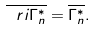Convert formula to latex. <formula><loc_0><loc_0><loc_500><loc_500>\overline { \ r i { \Gamma ^ { * } _ { n } } } = \overline { \Gamma ^ { * } _ { n } } .</formula> 